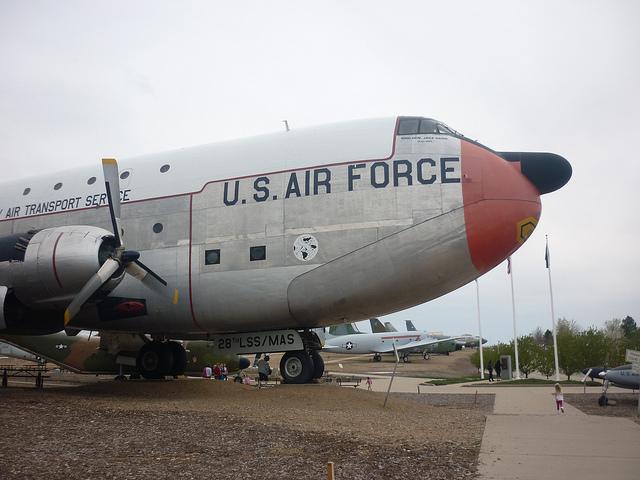What is the writing on the plain?
Quick response, please. Us air force. How many circle windows are there on the plane?
Keep it brief. 6. Is this a runway at an airport?
Concise answer only. No. What company is this?
Concise answer only. Us air force. Could this plane be from England?
Write a very short answer. No. What airline is the airplane from?
Concise answer only. Us air force. Is the image in black and white?
Answer briefly. No. What is in the right foreground with a person on it?
Quick response, please. Sidewalk. What country does it fly to?
Concise answer only. Usa. What colors make up the plane?
Write a very short answer. Gray white and black. Under the plane in the distance you can see a picture, what is it?
Quick response, please. Plane. What is the number just above the planes front tires?
Concise answer only. 28. Is this a passenger airplane?
Quick response, please. No. 